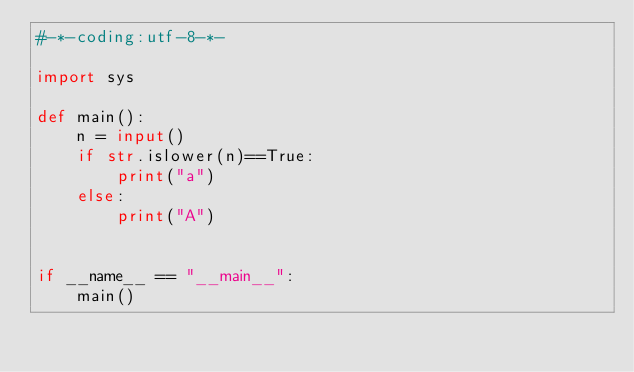Convert code to text. <code><loc_0><loc_0><loc_500><loc_500><_Python_>#-*-coding:utf-8-*-

import sys

def main():
    n = input()
    if str.islower(n)==True:
        print("a")
    else:
        print("A")
    

if __name__ == "__main__":
    main()
</code> 